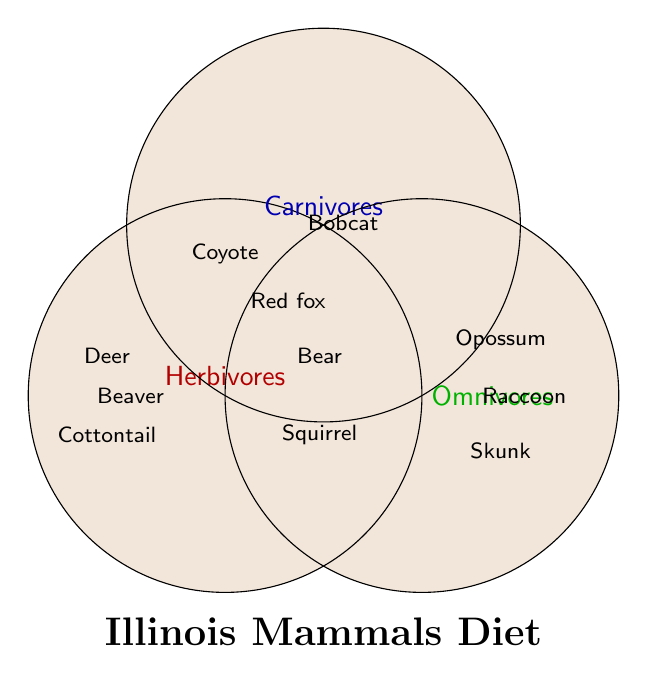Which species are categorized as herbivores? The herbivores section in the Venn diagram contains White-tailed deer, Eastern cottontail, Beaver.
Answer: White-tailed deer, Eastern cottontail, Beaver How many species are omnivores? The omnivores section in the Venn diagram contains Raccoon, Black bear, Opossum, Striped skunk, Coyote, Gray squirrel, Red fox.
Answer: 7 Which species are listed as both carnivores and omnivores but not herbivores? The intersection of carnivores and omnivores but not in herbivores contains Coyote, Red fox.
Answer: Coyote, Red fox Are there any species categorized under all three dietary habits? No species fall into the intersection of herbivores, carnivores, and omnivores in the Venn diagram.
Answer: No What is common between carnivores and herbivores? The intersection between carnivores and herbivores in the Venn diagram shows empty, indicating there are no common species.
Answer: None Which species is only categorized as a carnivore? The carnivores section that does not overlap with any other dietary habits shows Bobcat.
Answer: Bobcat Compare the number of species exclusive to herbivores and exclusive to omnivores. Herbivores have three exclusive species (White-tailed deer, Eastern cottontail, Beaver), whereas omnivores have four exclusive species (Raccoon, Black bear, Opossum, Striped skunk).
Answer: Herbivores: 3, Omnivores: 4 How many species are found only in one dietary category? Herbivores have three exclusive species, omnivores have four, and carnivores have one, summing to 3 + 4 + 1 = 8 species.
Answer: 8 